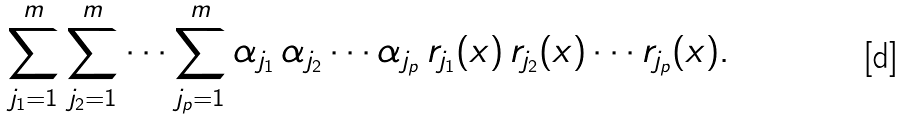<formula> <loc_0><loc_0><loc_500><loc_500>\sum _ { j _ { 1 } = 1 } ^ { m } \sum _ { j _ { 2 } = 1 } ^ { m } \cdots \sum _ { j _ { p } = 1 } ^ { m } \alpha _ { j _ { 1 } } \, \alpha _ { j _ { 2 } } \cdots \alpha _ { j _ { p } } \, r _ { j _ { 1 } } ( x ) \, r _ { j _ { 2 } } ( x ) \cdots r _ { j _ { p } } ( x ) .</formula> 